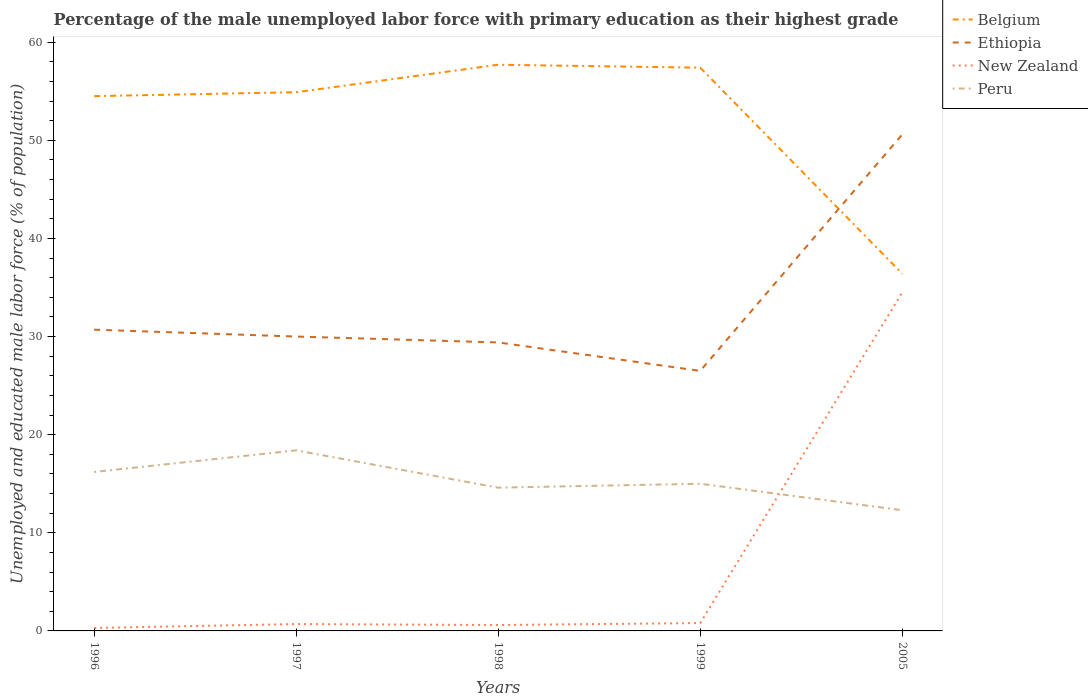Is the number of lines equal to the number of legend labels?
Provide a succinct answer. Yes. Across all years, what is the maximum percentage of the unemployed male labor force with primary education in Peru?
Keep it short and to the point. 12.3. What is the total percentage of the unemployed male labor force with primary education in New Zealand in the graph?
Offer a terse response. -0.3. What is the difference between the highest and the second highest percentage of the unemployed male labor force with primary education in Ethiopia?
Your response must be concise. 24.1. What is the difference between the highest and the lowest percentage of the unemployed male labor force with primary education in Ethiopia?
Your response must be concise. 1. How many lines are there?
Keep it short and to the point. 4. What is the difference between two consecutive major ticks on the Y-axis?
Make the answer very short. 10. Are the values on the major ticks of Y-axis written in scientific E-notation?
Give a very brief answer. No. How many legend labels are there?
Your answer should be compact. 4. How are the legend labels stacked?
Ensure brevity in your answer.  Vertical. What is the title of the graph?
Your response must be concise. Percentage of the male unemployed labor force with primary education as their highest grade. What is the label or title of the Y-axis?
Offer a terse response. Unemployed and educated male labor force (% of population). What is the Unemployed and educated male labor force (% of population) of Belgium in 1996?
Your response must be concise. 54.5. What is the Unemployed and educated male labor force (% of population) in Ethiopia in 1996?
Provide a succinct answer. 30.7. What is the Unemployed and educated male labor force (% of population) in New Zealand in 1996?
Your answer should be compact. 0.3. What is the Unemployed and educated male labor force (% of population) in Peru in 1996?
Offer a terse response. 16.2. What is the Unemployed and educated male labor force (% of population) of Belgium in 1997?
Provide a short and direct response. 54.9. What is the Unemployed and educated male labor force (% of population) in Ethiopia in 1997?
Give a very brief answer. 30. What is the Unemployed and educated male labor force (% of population) of New Zealand in 1997?
Make the answer very short. 0.7. What is the Unemployed and educated male labor force (% of population) in Peru in 1997?
Ensure brevity in your answer.  18.4. What is the Unemployed and educated male labor force (% of population) of Belgium in 1998?
Ensure brevity in your answer.  57.7. What is the Unemployed and educated male labor force (% of population) in Ethiopia in 1998?
Keep it short and to the point. 29.4. What is the Unemployed and educated male labor force (% of population) of New Zealand in 1998?
Keep it short and to the point. 0.6. What is the Unemployed and educated male labor force (% of population) in Peru in 1998?
Your response must be concise. 14.6. What is the Unemployed and educated male labor force (% of population) in Belgium in 1999?
Make the answer very short. 57.4. What is the Unemployed and educated male labor force (% of population) of New Zealand in 1999?
Your answer should be compact. 0.8. What is the Unemployed and educated male labor force (% of population) of Peru in 1999?
Give a very brief answer. 15. What is the Unemployed and educated male labor force (% of population) in Belgium in 2005?
Ensure brevity in your answer.  36.4. What is the Unemployed and educated male labor force (% of population) in Ethiopia in 2005?
Provide a short and direct response. 50.6. What is the Unemployed and educated male labor force (% of population) in New Zealand in 2005?
Provide a short and direct response. 34.5. What is the Unemployed and educated male labor force (% of population) in Peru in 2005?
Offer a terse response. 12.3. Across all years, what is the maximum Unemployed and educated male labor force (% of population) in Belgium?
Your answer should be compact. 57.7. Across all years, what is the maximum Unemployed and educated male labor force (% of population) of Ethiopia?
Provide a succinct answer. 50.6. Across all years, what is the maximum Unemployed and educated male labor force (% of population) of New Zealand?
Your answer should be compact. 34.5. Across all years, what is the maximum Unemployed and educated male labor force (% of population) in Peru?
Provide a succinct answer. 18.4. Across all years, what is the minimum Unemployed and educated male labor force (% of population) of Belgium?
Give a very brief answer. 36.4. Across all years, what is the minimum Unemployed and educated male labor force (% of population) in Ethiopia?
Provide a succinct answer. 26.5. Across all years, what is the minimum Unemployed and educated male labor force (% of population) of New Zealand?
Your answer should be very brief. 0.3. Across all years, what is the minimum Unemployed and educated male labor force (% of population) of Peru?
Make the answer very short. 12.3. What is the total Unemployed and educated male labor force (% of population) in Belgium in the graph?
Make the answer very short. 260.9. What is the total Unemployed and educated male labor force (% of population) of Ethiopia in the graph?
Offer a very short reply. 167.2. What is the total Unemployed and educated male labor force (% of population) of New Zealand in the graph?
Offer a terse response. 36.9. What is the total Unemployed and educated male labor force (% of population) in Peru in the graph?
Provide a short and direct response. 76.5. What is the difference between the Unemployed and educated male labor force (% of population) of Ethiopia in 1996 and that in 1997?
Offer a terse response. 0.7. What is the difference between the Unemployed and educated male labor force (% of population) in Belgium in 1996 and that in 1998?
Provide a short and direct response. -3.2. What is the difference between the Unemployed and educated male labor force (% of population) in New Zealand in 1996 and that in 1998?
Offer a terse response. -0.3. What is the difference between the Unemployed and educated male labor force (% of population) in Belgium in 1996 and that in 1999?
Make the answer very short. -2.9. What is the difference between the Unemployed and educated male labor force (% of population) in Ethiopia in 1996 and that in 1999?
Give a very brief answer. 4.2. What is the difference between the Unemployed and educated male labor force (% of population) of Peru in 1996 and that in 1999?
Offer a very short reply. 1.2. What is the difference between the Unemployed and educated male labor force (% of population) in Ethiopia in 1996 and that in 2005?
Offer a very short reply. -19.9. What is the difference between the Unemployed and educated male labor force (% of population) of New Zealand in 1996 and that in 2005?
Ensure brevity in your answer.  -34.2. What is the difference between the Unemployed and educated male labor force (% of population) in Peru in 1996 and that in 2005?
Provide a succinct answer. 3.9. What is the difference between the Unemployed and educated male labor force (% of population) of New Zealand in 1997 and that in 1998?
Make the answer very short. 0.1. What is the difference between the Unemployed and educated male labor force (% of population) in Belgium in 1997 and that in 2005?
Keep it short and to the point. 18.5. What is the difference between the Unemployed and educated male labor force (% of population) of Ethiopia in 1997 and that in 2005?
Give a very brief answer. -20.6. What is the difference between the Unemployed and educated male labor force (% of population) of New Zealand in 1997 and that in 2005?
Your answer should be compact. -33.8. What is the difference between the Unemployed and educated male labor force (% of population) of New Zealand in 1998 and that in 1999?
Your answer should be compact. -0.2. What is the difference between the Unemployed and educated male labor force (% of population) of Peru in 1998 and that in 1999?
Provide a short and direct response. -0.4. What is the difference between the Unemployed and educated male labor force (% of population) in Belgium in 1998 and that in 2005?
Make the answer very short. 21.3. What is the difference between the Unemployed and educated male labor force (% of population) in Ethiopia in 1998 and that in 2005?
Your answer should be compact. -21.2. What is the difference between the Unemployed and educated male labor force (% of population) of New Zealand in 1998 and that in 2005?
Give a very brief answer. -33.9. What is the difference between the Unemployed and educated male labor force (% of population) of Peru in 1998 and that in 2005?
Give a very brief answer. 2.3. What is the difference between the Unemployed and educated male labor force (% of population) of Belgium in 1999 and that in 2005?
Offer a very short reply. 21. What is the difference between the Unemployed and educated male labor force (% of population) of Ethiopia in 1999 and that in 2005?
Keep it short and to the point. -24.1. What is the difference between the Unemployed and educated male labor force (% of population) of New Zealand in 1999 and that in 2005?
Offer a terse response. -33.7. What is the difference between the Unemployed and educated male labor force (% of population) in Peru in 1999 and that in 2005?
Your answer should be very brief. 2.7. What is the difference between the Unemployed and educated male labor force (% of population) of Belgium in 1996 and the Unemployed and educated male labor force (% of population) of New Zealand in 1997?
Provide a short and direct response. 53.8. What is the difference between the Unemployed and educated male labor force (% of population) of Belgium in 1996 and the Unemployed and educated male labor force (% of population) of Peru in 1997?
Offer a very short reply. 36.1. What is the difference between the Unemployed and educated male labor force (% of population) of Ethiopia in 1996 and the Unemployed and educated male labor force (% of population) of New Zealand in 1997?
Ensure brevity in your answer.  30. What is the difference between the Unemployed and educated male labor force (% of population) in Ethiopia in 1996 and the Unemployed and educated male labor force (% of population) in Peru in 1997?
Your answer should be compact. 12.3. What is the difference between the Unemployed and educated male labor force (% of population) in New Zealand in 1996 and the Unemployed and educated male labor force (% of population) in Peru in 1997?
Offer a very short reply. -18.1. What is the difference between the Unemployed and educated male labor force (% of population) of Belgium in 1996 and the Unemployed and educated male labor force (% of population) of Ethiopia in 1998?
Your answer should be very brief. 25.1. What is the difference between the Unemployed and educated male labor force (% of population) in Belgium in 1996 and the Unemployed and educated male labor force (% of population) in New Zealand in 1998?
Make the answer very short. 53.9. What is the difference between the Unemployed and educated male labor force (% of population) in Belgium in 1996 and the Unemployed and educated male labor force (% of population) in Peru in 1998?
Your answer should be compact. 39.9. What is the difference between the Unemployed and educated male labor force (% of population) in Ethiopia in 1996 and the Unemployed and educated male labor force (% of population) in New Zealand in 1998?
Provide a succinct answer. 30.1. What is the difference between the Unemployed and educated male labor force (% of population) in Ethiopia in 1996 and the Unemployed and educated male labor force (% of population) in Peru in 1998?
Provide a succinct answer. 16.1. What is the difference between the Unemployed and educated male labor force (% of population) of New Zealand in 1996 and the Unemployed and educated male labor force (% of population) of Peru in 1998?
Provide a short and direct response. -14.3. What is the difference between the Unemployed and educated male labor force (% of population) in Belgium in 1996 and the Unemployed and educated male labor force (% of population) in New Zealand in 1999?
Give a very brief answer. 53.7. What is the difference between the Unemployed and educated male labor force (% of population) of Belgium in 1996 and the Unemployed and educated male labor force (% of population) of Peru in 1999?
Give a very brief answer. 39.5. What is the difference between the Unemployed and educated male labor force (% of population) in Ethiopia in 1996 and the Unemployed and educated male labor force (% of population) in New Zealand in 1999?
Ensure brevity in your answer.  29.9. What is the difference between the Unemployed and educated male labor force (% of population) in Ethiopia in 1996 and the Unemployed and educated male labor force (% of population) in Peru in 1999?
Your answer should be very brief. 15.7. What is the difference between the Unemployed and educated male labor force (% of population) in New Zealand in 1996 and the Unemployed and educated male labor force (% of population) in Peru in 1999?
Offer a very short reply. -14.7. What is the difference between the Unemployed and educated male labor force (% of population) in Belgium in 1996 and the Unemployed and educated male labor force (% of population) in Peru in 2005?
Your answer should be very brief. 42.2. What is the difference between the Unemployed and educated male labor force (% of population) in Ethiopia in 1996 and the Unemployed and educated male labor force (% of population) in New Zealand in 2005?
Offer a very short reply. -3.8. What is the difference between the Unemployed and educated male labor force (% of population) in New Zealand in 1996 and the Unemployed and educated male labor force (% of population) in Peru in 2005?
Keep it short and to the point. -12. What is the difference between the Unemployed and educated male labor force (% of population) in Belgium in 1997 and the Unemployed and educated male labor force (% of population) in Ethiopia in 1998?
Your answer should be compact. 25.5. What is the difference between the Unemployed and educated male labor force (% of population) in Belgium in 1997 and the Unemployed and educated male labor force (% of population) in New Zealand in 1998?
Provide a succinct answer. 54.3. What is the difference between the Unemployed and educated male labor force (% of population) of Belgium in 1997 and the Unemployed and educated male labor force (% of population) of Peru in 1998?
Make the answer very short. 40.3. What is the difference between the Unemployed and educated male labor force (% of population) in Ethiopia in 1997 and the Unemployed and educated male labor force (% of population) in New Zealand in 1998?
Your response must be concise. 29.4. What is the difference between the Unemployed and educated male labor force (% of population) of Ethiopia in 1997 and the Unemployed and educated male labor force (% of population) of Peru in 1998?
Your answer should be very brief. 15.4. What is the difference between the Unemployed and educated male labor force (% of population) of New Zealand in 1997 and the Unemployed and educated male labor force (% of population) of Peru in 1998?
Keep it short and to the point. -13.9. What is the difference between the Unemployed and educated male labor force (% of population) of Belgium in 1997 and the Unemployed and educated male labor force (% of population) of Ethiopia in 1999?
Offer a very short reply. 28.4. What is the difference between the Unemployed and educated male labor force (% of population) in Belgium in 1997 and the Unemployed and educated male labor force (% of population) in New Zealand in 1999?
Offer a terse response. 54.1. What is the difference between the Unemployed and educated male labor force (% of population) in Belgium in 1997 and the Unemployed and educated male labor force (% of population) in Peru in 1999?
Provide a short and direct response. 39.9. What is the difference between the Unemployed and educated male labor force (% of population) of Ethiopia in 1997 and the Unemployed and educated male labor force (% of population) of New Zealand in 1999?
Make the answer very short. 29.2. What is the difference between the Unemployed and educated male labor force (% of population) of Ethiopia in 1997 and the Unemployed and educated male labor force (% of population) of Peru in 1999?
Keep it short and to the point. 15. What is the difference between the Unemployed and educated male labor force (% of population) in New Zealand in 1997 and the Unemployed and educated male labor force (% of population) in Peru in 1999?
Your answer should be compact. -14.3. What is the difference between the Unemployed and educated male labor force (% of population) of Belgium in 1997 and the Unemployed and educated male labor force (% of population) of New Zealand in 2005?
Offer a very short reply. 20.4. What is the difference between the Unemployed and educated male labor force (% of population) of Belgium in 1997 and the Unemployed and educated male labor force (% of population) of Peru in 2005?
Give a very brief answer. 42.6. What is the difference between the Unemployed and educated male labor force (% of population) in Ethiopia in 1997 and the Unemployed and educated male labor force (% of population) in Peru in 2005?
Give a very brief answer. 17.7. What is the difference between the Unemployed and educated male labor force (% of population) of Belgium in 1998 and the Unemployed and educated male labor force (% of population) of Ethiopia in 1999?
Ensure brevity in your answer.  31.2. What is the difference between the Unemployed and educated male labor force (% of population) in Belgium in 1998 and the Unemployed and educated male labor force (% of population) in New Zealand in 1999?
Offer a terse response. 56.9. What is the difference between the Unemployed and educated male labor force (% of population) of Belgium in 1998 and the Unemployed and educated male labor force (% of population) of Peru in 1999?
Your answer should be very brief. 42.7. What is the difference between the Unemployed and educated male labor force (% of population) of Ethiopia in 1998 and the Unemployed and educated male labor force (% of population) of New Zealand in 1999?
Your response must be concise. 28.6. What is the difference between the Unemployed and educated male labor force (% of population) in Ethiopia in 1998 and the Unemployed and educated male labor force (% of population) in Peru in 1999?
Your response must be concise. 14.4. What is the difference between the Unemployed and educated male labor force (% of population) in New Zealand in 1998 and the Unemployed and educated male labor force (% of population) in Peru in 1999?
Your answer should be very brief. -14.4. What is the difference between the Unemployed and educated male labor force (% of population) in Belgium in 1998 and the Unemployed and educated male labor force (% of population) in New Zealand in 2005?
Ensure brevity in your answer.  23.2. What is the difference between the Unemployed and educated male labor force (% of population) of Belgium in 1998 and the Unemployed and educated male labor force (% of population) of Peru in 2005?
Keep it short and to the point. 45.4. What is the difference between the Unemployed and educated male labor force (% of population) in Ethiopia in 1998 and the Unemployed and educated male labor force (% of population) in New Zealand in 2005?
Give a very brief answer. -5.1. What is the difference between the Unemployed and educated male labor force (% of population) in Ethiopia in 1998 and the Unemployed and educated male labor force (% of population) in Peru in 2005?
Offer a very short reply. 17.1. What is the difference between the Unemployed and educated male labor force (% of population) in Belgium in 1999 and the Unemployed and educated male labor force (% of population) in Ethiopia in 2005?
Provide a short and direct response. 6.8. What is the difference between the Unemployed and educated male labor force (% of population) of Belgium in 1999 and the Unemployed and educated male labor force (% of population) of New Zealand in 2005?
Give a very brief answer. 22.9. What is the difference between the Unemployed and educated male labor force (% of population) in Belgium in 1999 and the Unemployed and educated male labor force (% of population) in Peru in 2005?
Your answer should be very brief. 45.1. What is the difference between the Unemployed and educated male labor force (% of population) in New Zealand in 1999 and the Unemployed and educated male labor force (% of population) in Peru in 2005?
Your response must be concise. -11.5. What is the average Unemployed and educated male labor force (% of population) in Belgium per year?
Provide a succinct answer. 52.18. What is the average Unemployed and educated male labor force (% of population) in Ethiopia per year?
Keep it short and to the point. 33.44. What is the average Unemployed and educated male labor force (% of population) of New Zealand per year?
Offer a terse response. 7.38. In the year 1996, what is the difference between the Unemployed and educated male labor force (% of population) of Belgium and Unemployed and educated male labor force (% of population) of Ethiopia?
Provide a short and direct response. 23.8. In the year 1996, what is the difference between the Unemployed and educated male labor force (% of population) in Belgium and Unemployed and educated male labor force (% of population) in New Zealand?
Offer a very short reply. 54.2. In the year 1996, what is the difference between the Unemployed and educated male labor force (% of population) in Belgium and Unemployed and educated male labor force (% of population) in Peru?
Your response must be concise. 38.3. In the year 1996, what is the difference between the Unemployed and educated male labor force (% of population) of Ethiopia and Unemployed and educated male labor force (% of population) of New Zealand?
Offer a terse response. 30.4. In the year 1996, what is the difference between the Unemployed and educated male labor force (% of population) in Ethiopia and Unemployed and educated male labor force (% of population) in Peru?
Keep it short and to the point. 14.5. In the year 1996, what is the difference between the Unemployed and educated male labor force (% of population) in New Zealand and Unemployed and educated male labor force (% of population) in Peru?
Your answer should be compact. -15.9. In the year 1997, what is the difference between the Unemployed and educated male labor force (% of population) in Belgium and Unemployed and educated male labor force (% of population) in Ethiopia?
Provide a succinct answer. 24.9. In the year 1997, what is the difference between the Unemployed and educated male labor force (% of population) of Belgium and Unemployed and educated male labor force (% of population) of New Zealand?
Ensure brevity in your answer.  54.2. In the year 1997, what is the difference between the Unemployed and educated male labor force (% of population) in Belgium and Unemployed and educated male labor force (% of population) in Peru?
Give a very brief answer. 36.5. In the year 1997, what is the difference between the Unemployed and educated male labor force (% of population) of Ethiopia and Unemployed and educated male labor force (% of population) of New Zealand?
Keep it short and to the point. 29.3. In the year 1997, what is the difference between the Unemployed and educated male labor force (% of population) in New Zealand and Unemployed and educated male labor force (% of population) in Peru?
Offer a very short reply. -17.7. In the year 1998, what is the difference between the Unemployed and educated male labor force (% of population) in Belgium and Unemployed and educated male labor force (% of population) in Ethiopia?
Make the answer very short. 28.3. In the year 1998, what is the difference between the Unemployed and educated male labor force (% of population) of Belgium and Unemployed and educated male labor force (% of population) of New Zealand?
Provide a short and direct response. 57.1. In the year 1998, what is the difference between the Unemployed and educated male labor force (% of population) of Belgium and Unemployed and educated male labor force (% of population) of Peru?
Offer a very short reply. 43.1. In the year 1998, what is the difference between the Unemployed and educated male labor force (% of population) of Ethiopia and Unemployed and educated male labor force (% of population) of New Zealand?
Your answer should be very brief. 28.8. In the year 1998, what is the difference between the Unemployed and educated male labor force (% of population) of Ethiopia and Unemployed and educated male labor force (% of population) of Peru?
Your response must be concise. 14.8. In the year 1998, what is the difference between the Unemployed and educated male labor force (% of population) in New Zealand and Unemployed and educated male labor force (% of population) in Peru?
Your answer should be compact. -14. In the year 1999, what is the difference between the Unemployed and educated male labor force (% of population) in Belgium and Unemployed and educated male labor force (% of population) in Ethiopia?
Ensure brevity in your answer.  30.9. In the year 1999, what is the difference between the Unemployed and educated male labor force (% of population) in Belgium and Unemployed and educated male labor force (% of population) in New Zealand?
Make the answer very short. 56.6. In the year 1999, what is the difference between the Unemployed and educated male labor force (% of population) of Belgium and Unemployed and educated male labor force (% of population) of Peru?
Provide a short and direct response. 42.4. In the year 1999, what is the difference between the Unemployed and educated male labor force (% of population) of Ethiopia and Unemployed and educated male labor force (% of population) of New Zealand?
Offer a very short reply. 25.7. In the year 2005, what is the difference between the Unemployed and educated male labor force (% of population) of Belgium and Unemployed and educated male labor force (% of population) of Ethiopia?
Your answer should be compact. -14.2. In the year 2005, what is the difference between the Unemployed and educated male labor force (% of population) in Belgium and Unemployed and educated male labor force (% of population) in Peru?
Make the answer very short. 24.1. In the year 2005, what is the difference between the Unemployed and educated male labor force (% of population) in Ethiopia and Unemployed and educated male labor force (% of population) in Peru?
Ensure brevity in your answer.  38.3. In the year 2005, what is the difference between the Unemployed and educated male labor force (% of population) of New Zealand and Unemployed and educated male labor force (% of population) of Peru?
Keep it short and to the point. 22.2. What is the ratio of the Unemployed and educated male labor force (% of population) of Ethiopia in 1996 to that in 1997?
Ensure brevity in your answer.  1.02. What is the ratio of the Unemployed and educated male labor force (% of population) in New Zealand in 1996 to that in 1997?
Make the answer very short. 0.43. What is the ratio of the Unemployed and educated male labor force (% of population) in Peru in 1996 to that in 1997?
Your response must be concise. 0.88. What is the ratio of the Unemployed and educated male labor force (% of population) in Belgium in 1996 to that in 1998?
Offer a terse response. 0.94. What is the ratio of the Unemployed and educated male labor force (% of population) in Ethiopia in 1996 to that in 1998?
Give a very brief answer. 1.04. What is the ratio of the Unemployed and educated male labor force (% of population) in Peru in 1996 to that in 1998?
Your answer should be compact. 1.11. What is the ratio of the Unemployed and educated male labor force (% of population) of Belgium in 1996 to that in 1999?
Your response must be concise. 0.95. What is the ratio of the Unemployed and educated male labor force (% of population) of Ethiopia in 1996 to that in 1999?
Keep it short and to the point. 1.16. What is the ratio of the Unemployed and educated male labor force (% of population) in Peru in 1996 to that in 1999?
Ensure brevity in your answer.  1.08. What is the ratio of the Unemployed and educated male labor force (% of population) in Belgium in 1996 to that in 2005?
Give a very brief answer. 1.5. What is the ratio of the Unemployed and educated male labor force (% of population) of Ethiopia in 1996 to that in 2005?
Give a very brief answer. 0.61. What is the ratio of the Unemployed and educated male labor force (% of population) of New Zealand in 1996 to that in 2005?
Your response must be concise. 0.01. What is the ratio of the Unemployed and educated male labor force (% of population) in Peru in 1996 to that in 2005?
Ensure brevity in your answer.  1.32. What is the ratio of the Unemployed and educated male labor force (% of population) in Belgium in 1997 to that in 1998?
Provide a succinct answer. 0.95. What is the ratio of the Unemployed and educated male labor force (% of population) in Ethiopia in 1997 to that in 1998?
Offer a terse response. 1.02. What is the ratio of the Unemployed and educated male labor force (% of population) of New Zealand in 1997 to that in 1998?
Offer a very short reply. 1.17. What is the ratio of the Unemployed and educated male labor force (% of population) of Peru in 1997 to that in 1998?
Your answer should be compact. 1.26. What is the ratio of the Unemployed and educated male labor force (% of population) in Belgium in 1997 to that in 1999?
Keep it short and to the point. 0.96. What is the ratio of the Unemployed and educated male labor force (% of population) in Ethiopia in 1997 to that in 1999?
Keep it short and to the point. 1.13. What is the ratio of the Unemployed and educated male labor force (% of population) in New Zealand in 1997 to that in 1999?
Make the answer very short. 0.88. What is the ratio of the Unemployed and educated male labor force (% of population) in Peru in 1997 to that in 1999?
Your answer should be very brief. 1.23. What is the ratio of the Unemployed and educated male labor force (% of population) in Belgium in 1997 to that in 2005?
Offer a terse response. 1.51. What is the ratio of the Unemployed and educated male labor force (% of population) in Ethiopia in 1997 to that in 2005?
Give a very brief answer. 0.59. What is the ratio of the Unemployed and educated male labor force (% of population) in New Zealand in 1997 to that in 2005?
Provide a succinct answer. 0.02. What is the ratio of the Unemployed and educated male labor force (% of population) of Peru in 1997 to that in 2005?
Provide a succinct answer. 1.5. What is the ratio of the Unemployed and educated male labor force (% of population) in Belgium in 1998 to that in 1999?
Your answer should be very brief. 1.01. What is the ratio of the Unemployed and educated male labor force (% of population) of Ethiopia in 1998 to that in 1999?
Offer a terse response. 1.11. What is the ratio of the Unemployed and educated male labor force (% of population) in New Zealand in 1998 to that in 1999?
Your response must be concise. 0.75. What is the ratio of the Unemployed and educated male labor force (% of population) of Peru in 1998 to that in 1999?
Your answer should be compact. 0.97. What is the ratio of the Unemployed and educated male labor force (% of population) of Belgium in 1998 to that in 2005?
Your answer should be compact. 1.59. What is the ratio of the Unemployed and educated male labor force (% of population) in Ethiopia in 1998 to that in 2005?
Your response must be concise. 0.58. What is the ratio of the Unemployed and educated male labor force (% of population) in New Zealand in 1998 to that in 2005?
Your answer should be compact. 0.02. What is the ratio of the Unemployed and educated male labor force (% of population) in Peru in 1998 to that in 2005?
Your answer should be very brief. 1.19. What is the ratio of the Unemployed and educated male labor force (% of population) in Belgium in 1999 to that in 2005?
Offer a terse response. 1.58. What is the ratio of the Unemployed and educated male labor force (% of population) of Ethiopia in 1999 to that in 2005?
Offer a terse response. 0.52. What is the ratio of the Unemployed and educated male labor force (% of population) in New Zealand in 1999 to that in 2005?
Give a very brief answer. 0.02. What is the ratio of the Unemployed and educated male labor force (% of population) in Peru in 1999 to that in 2005?
Make the answer very short. 1.22. What is the difference between the highest and the second highest Unemployed and educated male labor force (% of population) of Belgium?
Your answer should be compact. 0.3. What is the difference between the highest and the second highest Unemployed and educated male labor force (% of population) of Ethiopia?
Offer a very short reply. 19.9. What is the difference between the highest and the second highest Unemployed and educated male labor force (% of population) of New Zealand?
Provide a short and direct response. 33.7. What is the difference between the highest and the second highest Unemployed and educated male labor force (% of population) of Peru?
Your answer should be compact. 2.2. What is the difference between the highest and the lowest Unemployed and educated male labor force (% of population) of Belgium?
Offer a very short reply. 21.3. What is the difference between the highest and the lowest Unemployed and educated male labor force (% of population) in Ethiopia?
Offer a very short reply. 24.1. What is the difference between the highest and the lowest Unemployed and educated male labor force (% of population) of New Zealand?
Provide a succinct answer. 34.2. What is the difference between the highest and the lowest Unemployed and educated male labor force (% of population) in Peru?
Give a very brief answer. 6.1. 